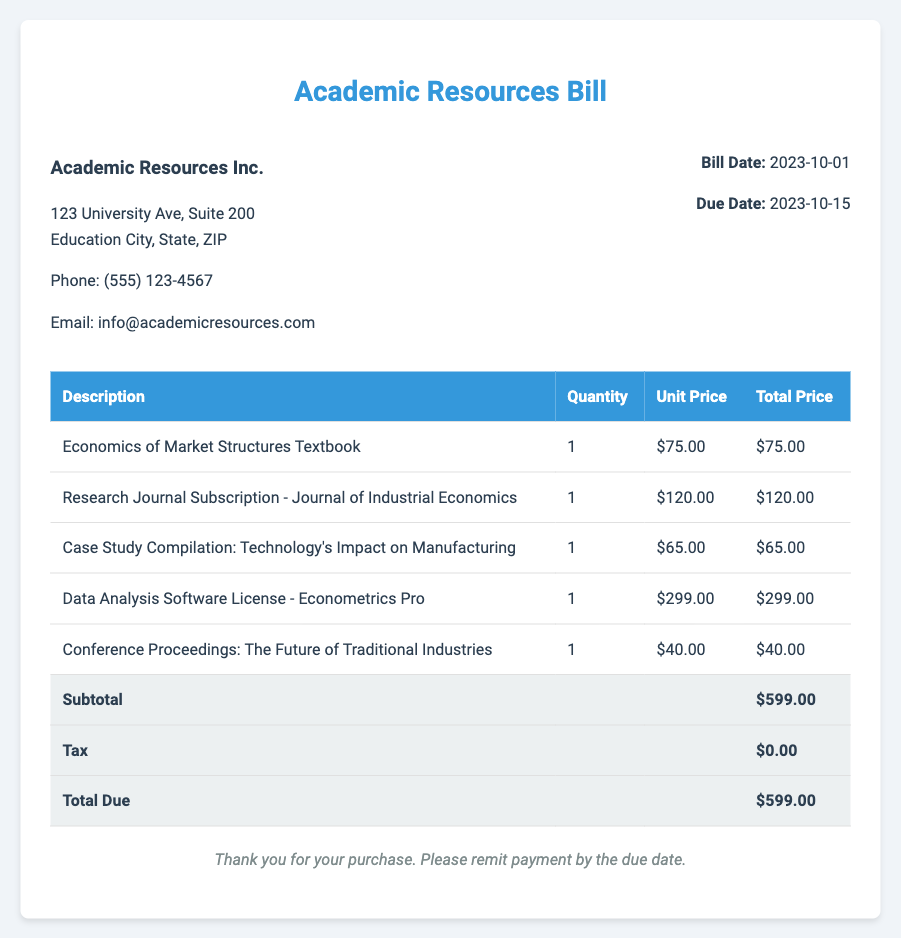What is the bill date? The bill date is clearly stated in the bill information section, which is October 1, 2023.
Answer: 2023-10-01 What is the total amount due? The total amount due is highlighted in the total section of the table, which sums up all itemized costs.
Answer: $599.00 Who is the vendor? The vendor information section contains the name of the vendor.
Answer: Academic Resources Inc What is the quantity of the Economics of Market Structures Textbook? The quantity is specified in the itemized costs table.
Answer: 1 How much does the Data Analysis Software License cost? The unit price for the item can be found in the table.
Answer: $299.00 What is the tax amount listed in the bill? The tax amount is mentioned in the total section of the table and is particularly noted to be zero.
Answer: $0.00 What is the due date for the payment? The due date is indicated in the bill information section.
Answer: 2023-10-15 Which item has the lowest cost? The item with the lowest cost can be identified from the itemized list.
Answer: Conference Proceedings: The Future of Traditional Industries What is the subtotal before tax? The subtotal is presented clearly in the total section and is separate from the tax amount.
Answer: $599.00 